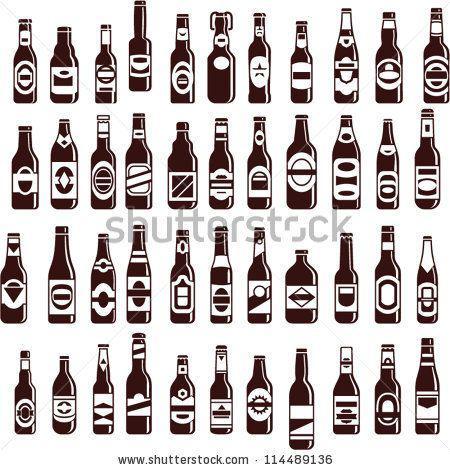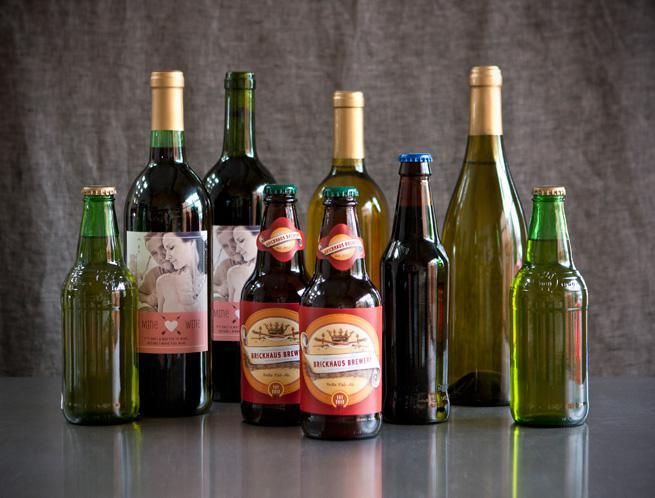The first image is the image on the left, the second image is the image on the right. Assess this claim about the two images: "In at least one image there are nine bottles of alcohol.". Correct or not? Answer yes or no. Yes. The first image is the image on the left, the second image is the image on the right. Analyze the images presented: Is the assertion "One image shows a variety of glass bottle shapes, colors and sizes displayed upright on a flat surface, with bottles overlapping." valid? Answer yes or no. Yes. 